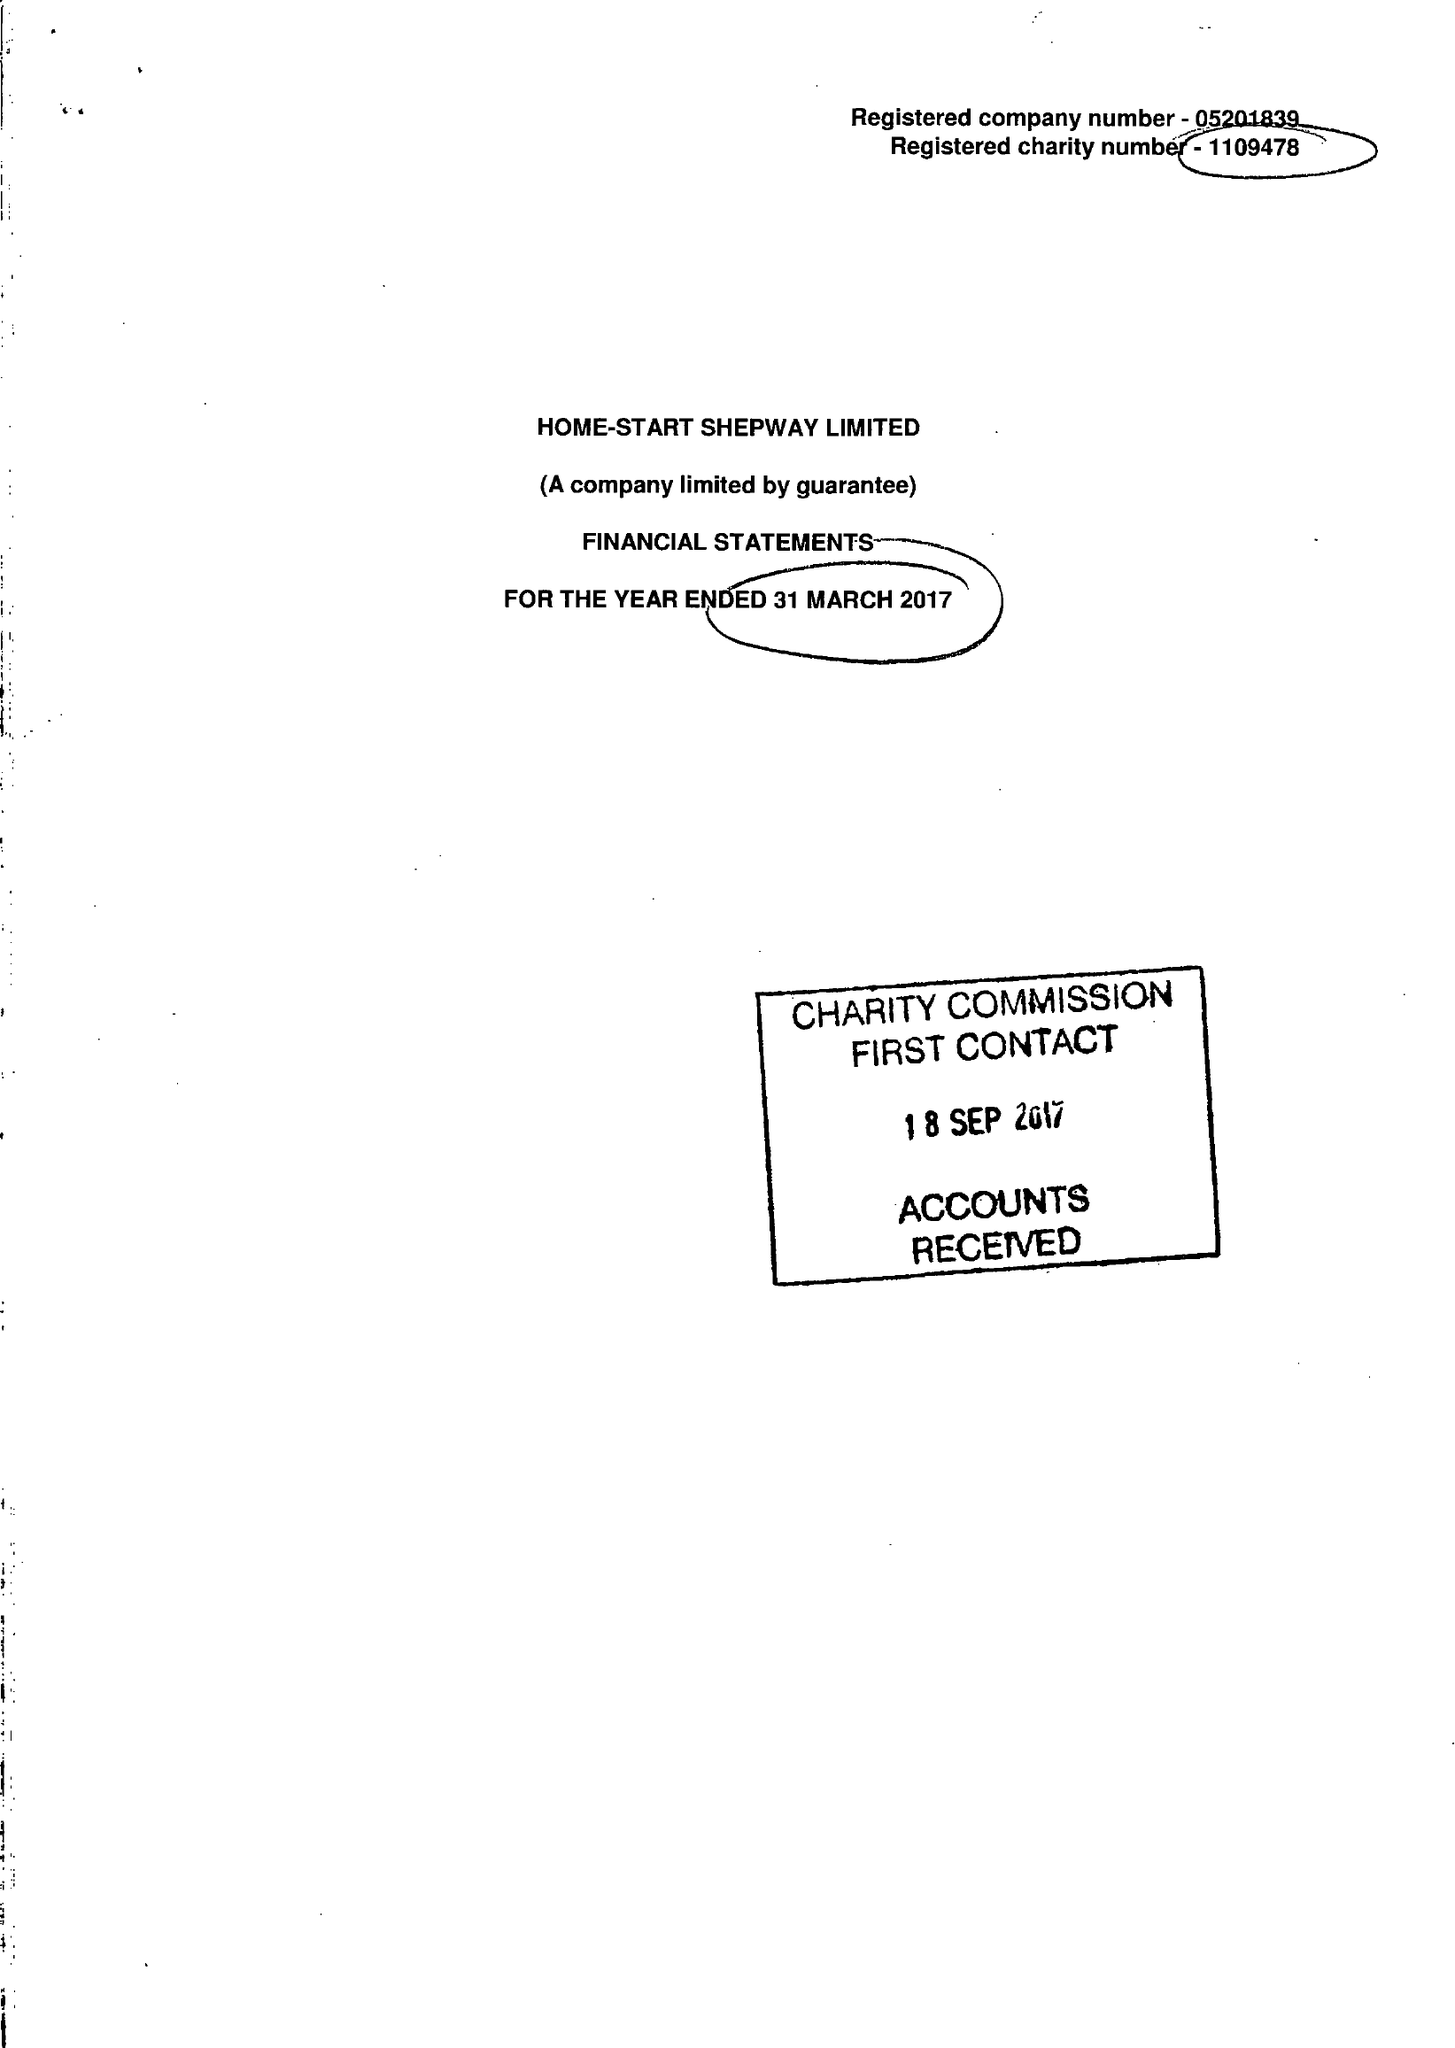What is the value for the address__post_town?
Answer the question using a single word or phrase. FOLKESTONE 